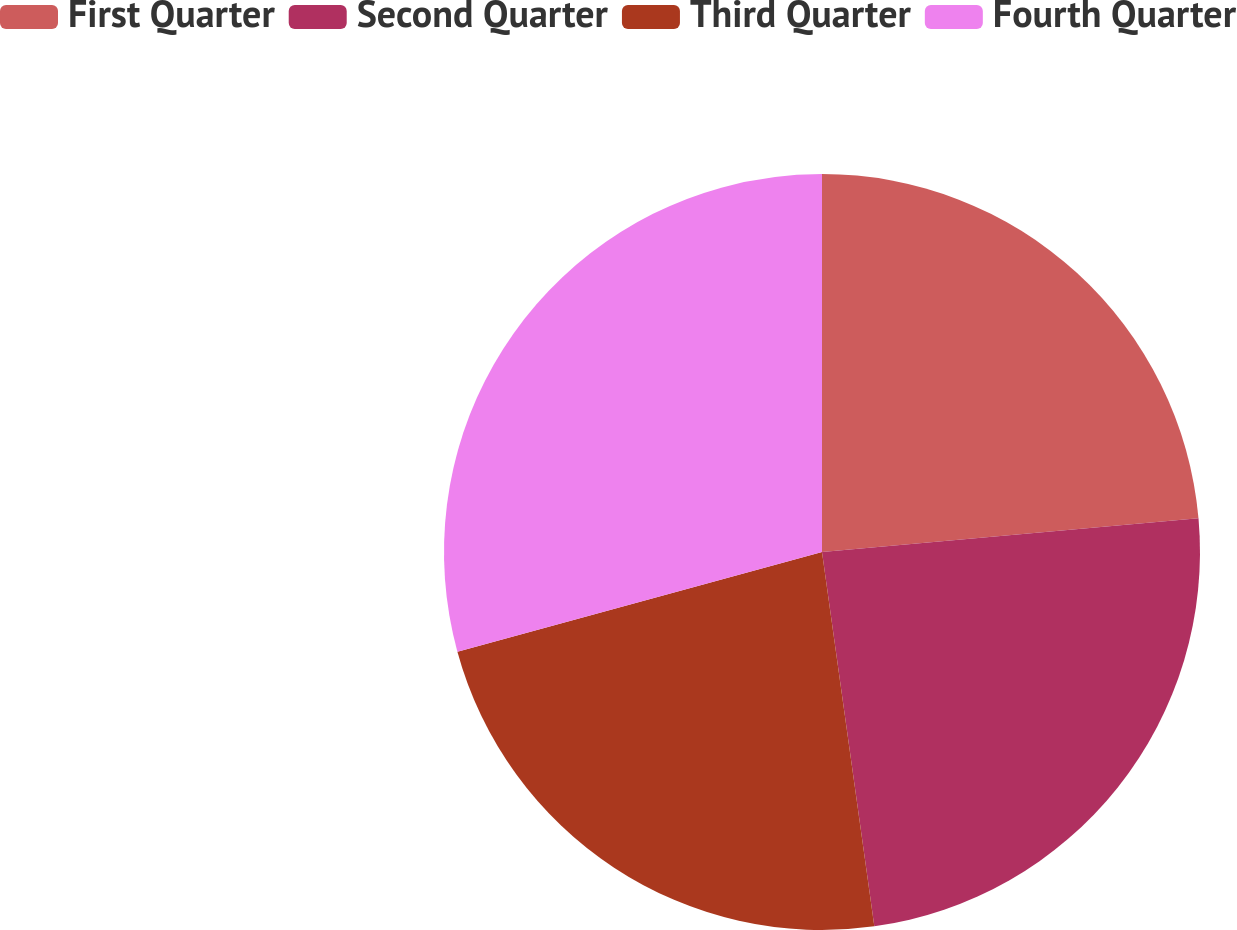Convert chart to OTSL. <chart><loc_0><loc_0><loc_500><loc_500><pie_chart><fcel>First Quarter<fcel>Second Quarter<fcel>Third Quarter<fcel>Fourth Quarter<nl><fcel>23.58%<fcel>24.21%<fcel>22.96%<fcel>29.25%<nl></chart> 